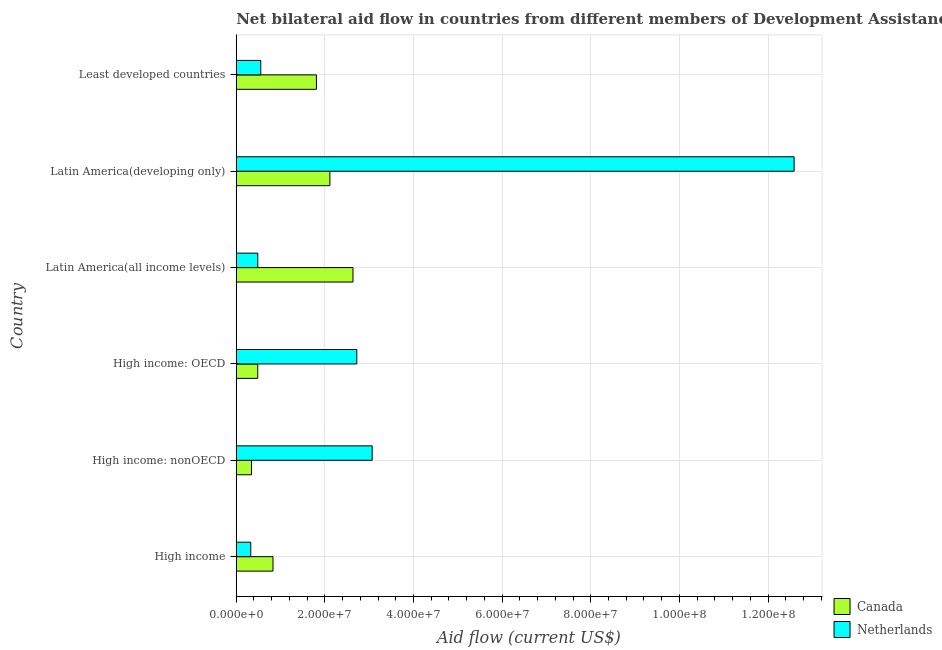How many groups of bars are there?
Make the answer very short. 6. How many bars are there on the 2nd tick from the top?
Ensure brevity in your answer.  2. How many bars are there on the 2nd tick from the bottom?
Your answer should be very brief. 2. What is the label of the 5th group of bars from the top?
Offer a terse response. High income: nonOECD. What is the amount of aid given by canada in High income: OECD?
Give a very brief answer. 4.85e+06. Across all countries, what is the maximum amount of aid given by netherlands?
Provide a short and direct response. 1.26e+08. Across all countries, what is the minimum amount of aid given by netherlands?
Your answer should be compact. 3.27e+06. In which country was the amount of aid given by canada maximum?
Provide a succinct answer. Latin America(all income levels). What is the total amount of aid given by netherlands in the graph?
Your answer should be compact. 1.97e+08. What is the difference between the amount of aid given by canada in High income and that in Latin America(all income levels)?
Give a very brief answer. -1.80e+07. What is the difference between the amount of aid given by netherlands in High income: OECD and the amount of aid given by canada in High income: nonOECD?
Give a very brief answer. 2.38e+07. What is the average amount of aid given by netherlands per country?
Provide a succinct answer. 3.29e+07. What is the difference between the amount of aid given by canada and amount of aid given by netherlands in Latin America(developing only)?
Offer a very short reply. -1.05e+08. What is the ratio of the amount of aid given by netherlands in Latin America(developing only) to that in Least developed countries?
Ensure brevity in your answer.  22.76. Is the difference between the amount of aid given by canada in High income: OECD and Latin America(all income levels) greater than the difference between the amount of aid given by netherlands in High income: OECD and Latin America(all income levels)?
Provide a succinct answer. No. What is the difference between the highest and the second highest amount of aid given by netherlands?
Your response must be concise. 9.52e+07. What is the difference between the highest and the lowest amount of aid given by canada?
Give a very brief answer. 2.29e+07. In how many countries, is the amount of aid given by canada greater than the average amount of aid given by canada taken over all countries?
Your response must be concise. 3. What does the 2nd bar from the bottom in High income represents?
Keep it short and to the point. Netherlands. How many bars are there?
Provide a succinct answer. 12. Are all the bars in the graph horizontal?
Your answer should be compact. Yes. How many countries are there in the graph?
Offer a terse response. 6. What is the difference between two consecutive major ticks on the X-axis?
Offer a very short reply. 2.00e+07. How many legend labels are there?
Keep it short and to the point. 2. How are the legend labels stacked?
Provide a succinct answer. Vertical. What is the title of the graph?
Offer a very short reply. Net bilateral aid flow in countries from different members of Development Assistance Committee. Does "UN agencies" appear as one of the legend labels in the graph?
Offer a very short reply. No. What is the label or title of the X-axis?
Make the answer very short. Aid flow (current US$). What is the label or title of the Y-axis?
Give a very brief answer. Country. What is the Aid flow (current US$) in Canada in High income?
Your answer should be compact. 8.29e+06. What is the Aid flow (current US$) in Netherlands in High income?
Provide a short and direct response. 3.27e+06. What is the Aid flow (current US$) in Canada in High income: nonOECD?
Provide a succinct answer. 3.44e+06. What is the Aid flow (current US$) of Netherlands in High income: nonOECD?
Ensure brevity in your answer.  3.07e+07. What is the Aid flow (current US$) of Canada in High income: OECD?
Provide a succinct answer. 4.85e+06. What is the Aid flow (current US$) in Netherlands in High income: OECD?
Keep it short and to the point. 2.72e+07. What is the Aid flow (current US$) of Canada in Latin America(all income levels)?
Your answer should be compact. 2.63e+07. What is the Aid flow (current US$) of Netherlands in Latin America(all income levels)?
Your answer should be compact. 4.86e+06. What is the Aid flow (current US$) of Canada in Latin America(developing only)?
Make the answer very short. 2.11e+07. What is the Aid flow (current US$) in Netherlands in Latin America(developing only)?
Ensure brevity in your answer.  1.26e+08. What is the Aid flow (current US$) in Canada in Least developed countries?
Keep it short and to the point. 1.81e+07. What is the Aid flow (current US$) of Netherlands in Least developed countries?
Your response must be concise. 5.53e+06. Across all countries, what is the maximum Aid flow (current US$) of Canada?
Keep it short and to the point. 2.63e+07. Across all countries, what is the maximum Aid flow (current US$) in Netherlands?
Provide a succinct answer. 1.26e+08. Across all countries, what is the minimum Aid flow (current US$) of Canada?
Make the answer very short. 3.44e+06. Across all countries, what is the minimum Aid flow (current US$) of Netherlands?
Provide a short and direct response. 3.27e+06. What is the total Aid flow (current US$) of Canada in the graph?
Your answer should be compact. 8.21e+07. What is the total Aid flow (current US$) of Netherlands in the graph?
Ensure brevity in your answer.  1.97e+08. What is the difference between the Aid flow (current US$) of Canada in High income and that in High income: nonOECD?
Your response must be concise. 4.85e+06. What is the difference between the Aid flow (current US$) in Netherlands in High income and that in High income: nonOECD?
Offer a terse response. -2.74e+07. What is the difference between the Aid flow (current US$) of Canada in High income and that in High income: OECD?
Provide a short and direct response. 3.44e+06. What is the difference between the Aid flow (current US$) in Netherlands in High income and that in High income: OECD?
Provide a short and direct response. -2.39e+07. What is the difference between the Aid flow (current US$) of Canada in High income and that in Latin America(all income levels)?
Offer a terse response. -1.80e+07. What is the difference between the Aid flow (current US$) in Netherlands in High income and that in Latin America(all income levels)?
Provide a short and direct response. -1.59e+06. What is the difference between the Aid flow (current US$) in Canada in High income and that in Latin America(developing only)?
Your answer should be very brief. -1.28e+07. What is the difference between the Aid flow (current US$) in Netherlands in High income and that in Latin America(developing only)?
Your answer should be very brief. -1.23e+08. What is the difference between the Aid flow (current US$) of Canada in High income and that in Least developed countries?
Give a very brief answer. -9.80e+06. What is the difference between the Aid flow (current US$) of Netherlands in High income and that in Least developed countries?
Give a very brief answer. -2.26e+06. What is the difference between the Aid flow (current US$) of Canada in High income: nonOECD and that in High income: OECD?
Provide a succinct answer. -1.41e+06. What is the difference between the Aid flow (current US$) of Netherlands in High income: nonOECD and that in High income: OECD?
Provide a succinct answer. 3.47e+06. What is the difference between the Aid flow (current US$) of Canada in High income: nonOECD and that in Latin America(all income levels)?
Offer a terse response. -2.29e+07. What is the difference between the Aid flow (current US$) of Netherlands in High income: nonOECD and that in Latin America(all income levels)?
Offer a very short reply. 2.58e+07. What is the difference between the Aid flow (current US$) of Canada in High income: nonOECD and that in Latin America(developing only)?
Ensure brevity in your answer.  -1.77e+07. What is the difference between the Aid flow (current US$) of Netherlands in High income: nonOECD and that in Latin America(developing only)?
Your answer should be compact. -9.52e+07. What is the difference between the Aid flow (current US$) of Canada in High income: nonOECD and that in Least developed countries?
Your answer should be very brief. -1.46e+07. What is the difference between the Aid flow (current US$) in Netherlands in High income: nonOECD and that in Least developed countries?
Make the answer very short. 2.51e+07. What is the difference between the Aid flow (current US$) in Canada in High income: OECD and that in Latin America(all income levels)?
Keep it short and to the point. -2.15e+07. What is the difference between the Aid flow (current US$) of Netherlands in High income: OECD and that in Latin America(all income levels)?
Provide a succinct answer. 2.23e+07. What is the difference between the Aid flow (current US$) of Canada in High income: OECD and that in Latin America(developing only)?
Your answer should be compact. -1.63e+07. What is the difference between the Aid flow (current US$) in Netherlands in High income: OECD and that in Latin America(developing only)?
Provide a succinct answer. -9.87e+07. What is the difference between the Aid flow (current US$) of Canada in High income: OECD and that in Least developed countries?
Give a very brief answer. -1.32e+07. What is the difference between the Aid flow (current US$) in Netherlands in High income: OECD and that in Least developed countries?
Your answer should be very brief. 2.17e+07. What is the difference between the Aid flow (current US$) of Canada in Latin America(all income levels) and that in Latin America(developing only)?
Ensure brevity in your answer.  5.21e+06. What is the difference between the Aid flow (current US$) in Netherlands in Latin America(all income levels) and that in Latin America(developing only)?
Provide a short and direct response. -1.21e+08. What is the difference between the Aid flow (current US$) in Canada in Latin America(all income levels) and that in Least developed countries?
Offer a very short reply. 8.25e+06. What is the difference between the Aid flow (current US$) of Netherlands in Latin America(all income levels) and that in Least developed countries?
Make the answer very short. -6.70e+05. What is the difference between the Aid flow (current US$) of Canada in Latin America(developing only) and that in Least developed countries?
Keep it short and to the point. 3.04e+06. What is the difference between the Aid flow (current US$) in Netherlands in Latin America(developing only) and that in Least developed countries?
Offer a very short reply. 1.20e+08. What is the difference between the Aid flow (current US$) of Canada in High income and the Aid flow (current US$) of Netherlands in High income: nonOECD?
Keep it short and to the point. -2.24e+07. What is the difference between the Aid flow (current US$) in Canada in High income and the Aid flow (current US$) in Netherlands in High income: OECD?
Your response must be concise. -1.89e+07. What is the difference between the Aid flow (current US$) of Canada in High income and the Aid flow (current US$) of Netherlands in Latin America(all income levels)?
Your answer should be compact. 3.43e+06. What is the difference between the Aid flow (current US$) in Canada in High income and the Aid flow (current US$) in Netherlands in Latin America(developing only)?
Give a very brief answer. -1.18e+08. What is the difference between the Aid flow (current US$) of Canada in High income and the Aid flow (current US$) of Netherlands in Least developed countries?
Provide a succinct answer. 2.76e+06. What is the difference between the Aid flow (current US$) of Canada in High income: nonOECD and the Aid flow (current US$) of Netherlands in High income: OECD?
Your answer should be compact. -2.38e+07. What is the difference between the Aid flow (current US$) of Canada in High income: nonOECD and the Aid flow (current US$) of Netherlands in Latin America(all income levels)?
Offer a very short reply. -1.42e+06. What is the difference between the Aid flow (current US$) in Canada in High income: nonOECD and the Aid flow (current US$) in Netherlands in Latin America(developing only)?
Make the answer very short. -1.22e+08. What is the difference between the Aid flow (current US$) of Canada in High income: nonOECD and the Aid flow (current US$) of Netherlands in Least developed countries?
Offer a very short reply. -2.09e+06. What is the difference between the Aid flow (current US$) of Canada in High income: OECD and the Aid flow (current US$) of Netherlands in Latin America(developing only)?
Provide a succinct answer. -1.21e+08. What is the difference between the Aid flow (current US$) in Canada in High income: OECD and the Aid flow (current US$) in Netherlands in Least developed countries?
Provide a short and direct response. -6.80e+05. What is the difference between the Aid flow (current US$) in Canada in Latin America(all income levels) and the Aid flow (current US$) in Netherlands in Latin America(developing only)?
Offer a very short reply. -9.95e+07. What is the difference between the Aid flow (current US$) in Canada in Latin America(all income levels) and the Aid flow (current US$) in Netherlands in Least developed countries?
Keep it short and to the point. 2.08e+07. What is the difference between the Aid flow (current US$) in Canada in Latin America(developing only) and the Aid flow (current US$) in Netherlands in Least developed countries?
Provide a succinct answer. 1.56e+07. What is the average Aid flow (current US$) in Canada per country?
Your answer should be very brief. 1.37e+07. What is the average Aid flow (current US$) of Netherlands per country?
Offer a terse response. 3.29e+07. What is the difference between the Aid flow (current US$) of Canada and Aid flow (current US$) of Netherlands in High income?
Offer a very short reply. 5.02e+06. What is the difference between the Aid flow (current US$) of Canada and Aid flow (current US$) of Netherlands in High income: nonOECD?
Make the answer very short. -2.72e+07. What is the difference between the Aid flow (current US$) of Canada and Aid flow (current US$) of Netherlands in High income: OECD?
Ensure brevity in your answer.  -2.24e+07. What is the difference between the Aid flow (current US$) in Canada and Aid flow (current US$) in Netherlands in Latin America(all income levels)?
Your answer should be very brief. 2.15e+07. What is the difference between the Aid flow (current US$) of Canada and Aid flow (current US$) of Netherlands in Latin America(developing only)?
Your answer should be very brief. -1.05e+08. What is the difference between the Aid flow (current US$) of Canada and Aid flow (current US$) of Netherlands in Least developed countries?
Your answer should be very brief. 1.26e+07. What is the ratio of the Aid flow (current US$) in Canada in High income to that in High income: nonOECD?
Provide a short and direct response. 2.41. What is the ratio of the Aid flow (current US$) in Netherlands in High income to that in High income: nonOECD?
Your answer should be compact. 0.11. What is the ratio of the Aid flow (current US$) of Canada in High income to that in High income: OECD?
Your answer should be compact. 1.71. What is the ratio of the Aid flow (current US$) in Netherlands in High income to that in High income: OECD?
Offer a very short reply. 0.12. What is the ratio of the Aid flow (current US$) in Canada in High income to that in Latin America(all income levels)?
Make the answer very short. 0.31. What is the ratio of the Aid flow (current US$) of Netherlands in High income to that in Latin America(all income levels)?
Keep it short and to the point. 0.67. What is the ratio of the Aid flow (current US$) of Canada in High income to that in Latin America(developing only)?
Your response must be concise. 0.39. What is the ratio of the Aid flow (current US$) of Netherlands in High income to that in Latin America(developing only)?
Ensure brevity in your answer.  0.03. What is the ratio of the Aid flow (current US$) of Canada in High income to that in Least developed countries?
Your answer should be very brief. 0.46. What is the ratio of the Aid flow (current US$) in Netherlands in High income to that in Least developed countries?
Offer a terse response. 0.59. What is the ratio of the Aid flow (current US$) in Canada in High income: nonOECD to that in High income: OECD?
Make the answer very short. 0.71. What is the ratio of the Aid flow (current US$) in Netherlands in High income: nonOECD to that in High income: OECD?
Your answer should be compact. 1.13. What is the ratio of the Aid flow (current US$) of Canada in High income: nonOECD to that in Latin America(all income levels)?
Provide a succinct answer. 0.13. What is the ratio of the Aid flow (current US$) in Netherlands in High income: nonOECD to that in Latin America(all income levels)?
Make the answer very short. 6.31. What is the ratio of the Aid flow (current US$) of Canada in High income: nonOECD to that in Latin America(developing only)?
Ensure brevity in your answer.  0.16. What is the ratio of the Aid flow (current US$) in Netherlands in High income: nonOECD to that in Latin America(developing only)?
Your answer should be compact. 0.24. What is the ratio of the Aid flow (current US$) in Canada in High income: nonOECD to that in Least developed countries?
Give a very brief answer. 0.19. What is the ratio of the Aid flow (current US$) in Netherlands in High income: nonOECD to that in Least developed countries?
Make the answer very short. 5.55. What is the ratio of the Aid flow (current US$) of Canada in High income: OECD to that in Latin America(all income levels)?
Your response must be concise. 0.18. What is the ratio of the Aid flow (current US$) in Netherlands in High income: OECD to that in Latin America(all income levels)?
Offer a terse response. 5.6. What is the ratio of the Aid flow (current US$) of Canada in High income: OECD to that in Latin America(developing only)?
Provide a short and direct response. 0.23. What is the ratio of the Aid flow (current US$) of Netherlands in High income: OECD to that in Latin America(developing only)?
Keep it short and to the point. 0.22. What is the ratio of the Aid flow (current US$) of Canada in High income: OECD to that in Least developed countries?
Offer a very short reply. 0.27. What is the ratio of the Aid flow (current US$) in Netherlands in High income: OECD to that in Least developed countries?
Provide a succinct answer. 4.92. What is the ratio of the Aid flow (current US$) in Canada in Latin America(all income levels) to that in Latin America(developing only)?
Your answer should be compact. 1.25. What is the ratio of the Aid flow (current US$) of Netherlands in Latin America(all income levels) to that in Latin America(developing only)?
Make the answer very short. 0.04. What is the ratio of the Aid flow (current US$) of Canada in Latin America(all income levels) to that in Least developed countries?
Make the answer very short. 1.46. What is the ratio of the Aid flow (current US$) in Netherlands in Latin America(all income levels) to that in Least developed countries?
Give a very brief answer. 0.88. What is the ratio of the Aid flow (current US$) in Canada in Latin America(developing only) to that in Least developed countries?
Offer a very short reply. 1.17. What is the ratio of the Aid flow (current US$) of Netherlands in Latin America(developing only) to that in Least developed countries?
Ensure brevity in your answer.  22.76. What is the difference between the highest and the second highest Aid flow (current US$) in Canada?
Give a very brief answer. 5.21e+06. What is the difference between the highest and the second highest Aid flow (current US$) of Netherlands?
Your response must be concise. 9.52e+07. What is the difference between the highest and the lowest Aid flow (current US$) of Canada?
Your answer should be compact. 2.29e+07. What is the difference between the highest and the lowest Aid flow (current US$) in Netherlands?
Ensure brevity in your answer.  1.23e+08. 